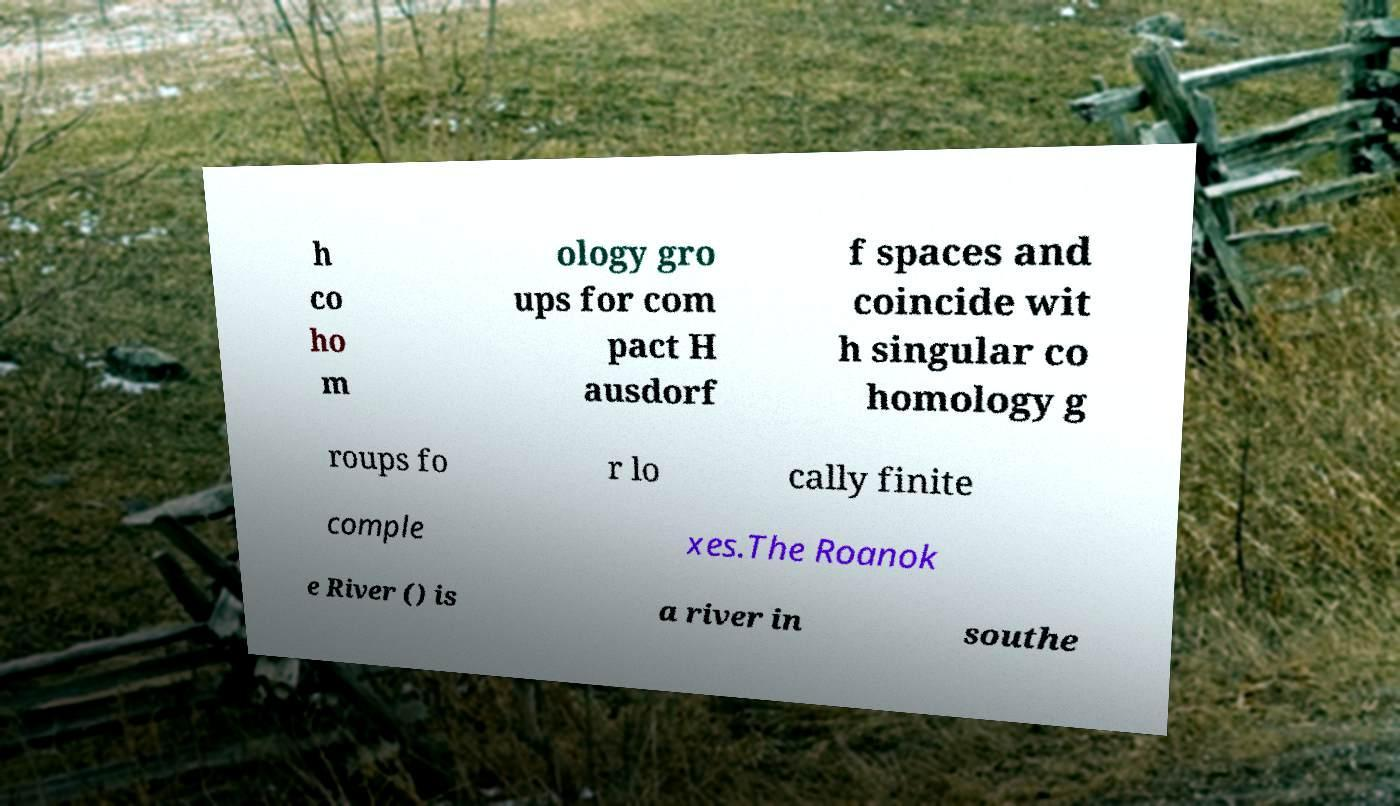Please read and relay the text visible in this image. What does it say? h co ho m ology gro ups for com pact H ausdorf f spaces and coincide wit h singular co homology g roups fo r lo cally finite comple xes.The Roanok e River () is a river in southe 